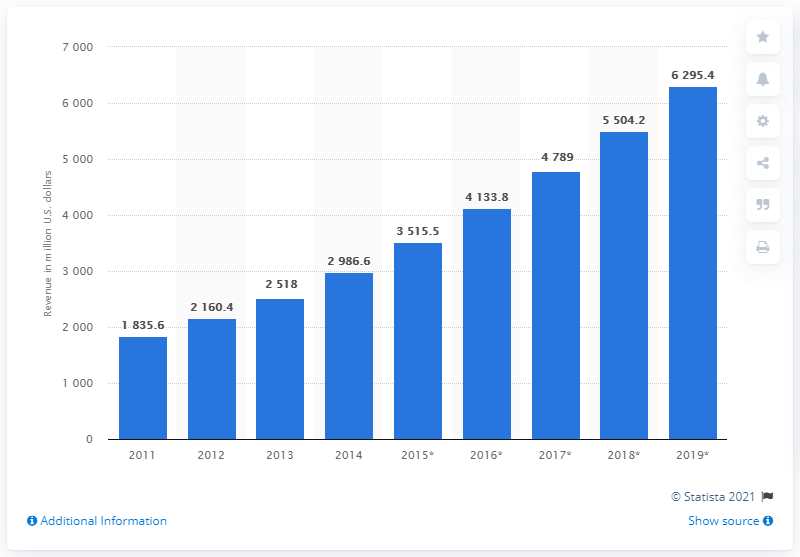Give some essential details in this illustration. The managed security services market generated approximately 2986.6 revenue in 2014. 